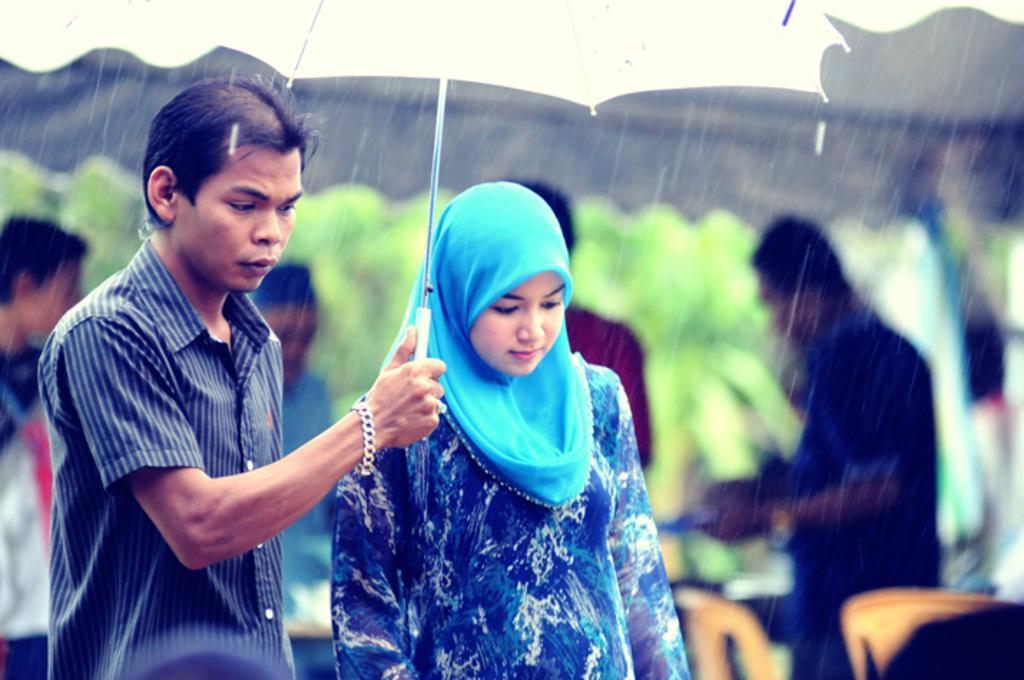Can you describe this image briefly? In this images we can see a man and a woman are under an umbrella and the man is holding an umbrella in his hand and it is raining. In he background the image is blur but we can see few persons, chairs, tent and trees. 